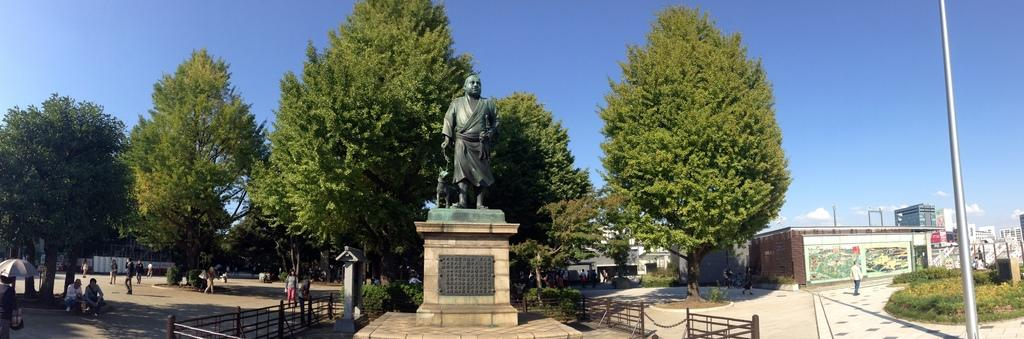What is depicted on the platform in the image? There is a sculpture of a person and an animal on a platform in the image. Who or what else can be seen in the image? There are people, a fence, a pole, an umbrella, trees, plants, buildings, and the sky visible in the image. What type of vegetation is present in the image? There are trees and plants in the image. What can be seen in the background of the image? There are buildings and the sky visible in the background of the image. What type of chin can be seen on the person in the sculpture? There is no chin visible on the person in the sculpture, as it is a sculpture and not a real person. 